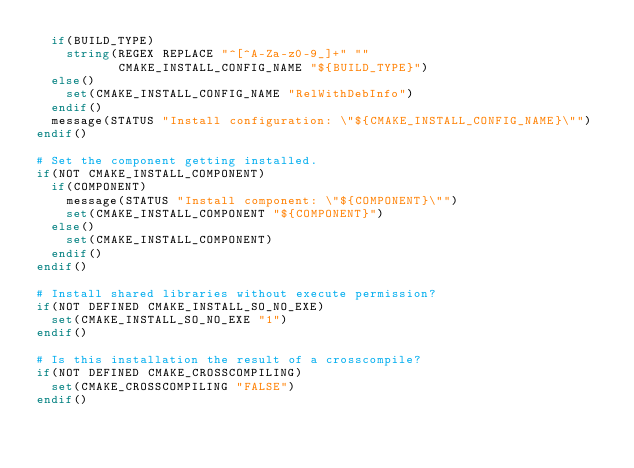Convert code to text. <code><loc_0><loc_0><loc_500><loc_500><_CMake_>  if(BUILD_TYPE)
    string(REGEX REPLACE "^[^A-Za-z0-9_]+" ""
           CMAKE_INSTALL_CONFIG_NAME "${BUILD_TYPE}")
  else()
    set(CMAKE_INSTALL_CONFIG_NAME "RelWithDebInfo")
  endif()
  message(STATUS "Install configuration: \"${CMAKE_INSTALL_CONFIG_NAME}\"")
endif()

# Set the component getting installed.
if(NOT CMAKE_INSTALL_COMPONENT)
  if(COMPONENT)
    message(STATUS "Install component: \"${COMPONENT}\"")
    set(CMAKE_INSTALL_COMPONENT "${COMPONENT}")
  else()
    set(CMAKE_INSTALL_COMPONENT)
  endif()
endif()

# Install shared libraries without execute permission?
if(NOT DEFINED CMAKE_INSTALL_SO_NO_EXE)
  set(CMAKE_INSTALL_SO_NO_EXE "1")
endif()

# Is this installation the result of a crosscompile?
if(NOT DEFINED CMAKE_CROSSCOMPILING)
  set(CMAKE_CROSSCOMPILING "FALSE")
endif()

</code> 